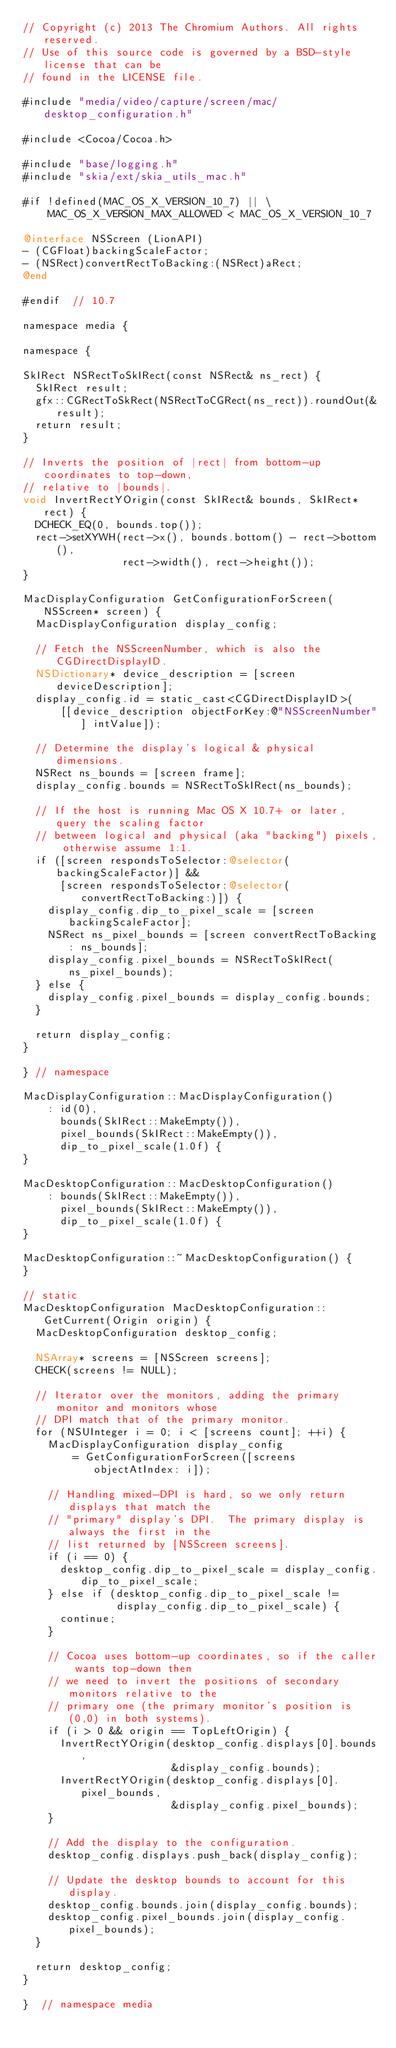<code> <loc_0><loc_0><loc_500><loc_500><_ObjectiveC_>// Copyright (c) 2013 The Chromium Authors. All rights reserved.
// Use of this source code is governed by a BSD-style license that can be
// found in the LICENSE file.

#include "media/video/capture/screen/mac/desktop_configuration.h"

#include <Cocoa/Cocoa.h>

#include "base/logging.h"
#include "skia/ext/skia_utils_mac.h"

#if !defined(MAC_OS_X_VERSION_10_7) || \
    MAC_OS_X_VERSION_MAX_ALLOWED < MAC_OS_X_VERSION_10_7

@interface NSScreen (LionAPI)
- (CGFloat)backingScaleFactor;
- (NSRect)convertRectToBacking:(NSRect)aRect;
@end

#endif  // 10.7

namespace media {

namespace {

SkIRect NSRectToSkIRect(const NSRect& ns_rect) {
  SkIRect result;
  gfx::CGRectToSkRect(NSRectToCGRect(ns_rect)).roundOut(&result);
  return result;
}

// Inverts the position of |rect| from bottom-up coordinates to top-down,
// relative to |bounds|.
void InvertRectYOrigin(const SkIRect& bounds, SkIRect* rect) {
  DCHECK_EQ(0, bounds.top());
  rect->setXYWH(rect->x(), bounds.bottom() - rect->bottom(),
                rect->width(), rect->height());
}

MacDisplayConfiguration GetConfigurationForScreen(NSScreen* screen) {
  MacDisplayConfiguration display_config;

  // Fetch the NSScreenNumber, which is also the CGDirectDisplayID.
  NSDictionary* device_description = [screen deviceDescription];
  display_config.id = static_cast<CGDirectDisplayID>(
      [[device_description objectForKey:@"NSScreenNumber"] intValue]);

  // Determine the display's logical & physical dimensions.
  NSRect ns_bounds = [screen frame];
  display_config.bounds = NSRectToSkIRect(ns_bounds);

  // If the host is running Mac OS X 10.7+ or later, query the scaling factor
  // between logical and physical (aka "backing") pixels, otherwise assume 1:1.
  if ([screen respondsToSelector:@selector(backingScaleFactor)] &&
      [screen respondsToSelector:@selector(convertRectToBacking:)]) {
    display_config.dip_to_pixel_scale = [screen backingScaleFactor];
    NSRect ns_pixel_bounds = [screen convertRectToBacking: ns_bounds];
    display_config.pixel_bounds = NSRectToSkIRect(ns_pixel_bounds);
  } else {
    display_config.pixel_bounds = display_config.bounds;
  }

  return display_config;
}

} // namespace

MacDisplayConfiguration::MacDisplayConfiguration()
    : id(0),
      bounds(SkIRect::MakeEmpty()),
      pixel_bounds(SkIRect::MakeEmpty()),
      dip_to_pixel_scale(1.0f) {
}

MacDesktopConfiguration::MacDesktopConfiguration()
    : bounds(SkIRect::MakeEmpty()),
      pixel_bounds(SkIRect::MakeEmpty()),
      dip_to_pixel_scale(1.0f) {
}

MacDesktopConfiguration::~MacDesktopConfiguration() {
}

// static
MacDesktopConfiguration MacDesktopConfiguration::GetCurrent(Origin origin) {
  MacDesktopConfiguration desktop_config;

  NSArray* screens = [NSScreen screens];
  CHECK(screens != NULL);

  // Iterator over the monitors, adding the primary monitor and monitors whose
  // DPI match that of the primary monitor.
  for (NSUInteger i = 0; i < [screens count]; ++i) {
    MacDisplayConfiguration display_config
        = GetConfigurationForScreen([screens objectAtIndex: i]);

    // Handling mixed-DPI is hard, so we only return displays that match the
    // "primary" display's DPI.  The primary display is always the first in the
    // list returned by [NSScreen screens].
    if (i == 0) {
      desktop_config.dip_to_pixel_scale = display_config.dip_to_pixel_scale;
    } else if (desktop_config.dip_to_pixel_scale !=
               display_config.dip_to_pixel_scale) {
      continue;
    }

    // Cocoa uses bottom-up coordinates, so if the caller wants top-down then
    // we need to invert the positions of secondary monitors relative to the
    // primary one (the primary monitor's position is (0,0) in both systems).
    if (i > 0 && origin == TopLeftOrigin) {
      InvertRectYOrigin(desktop_config.displays[0].bounds,
                        &display_config.bounds);
      InvertRectYOrigin(desktop_config.displays[0].pixel_bounds,
                        &display_config.pixel_bounds);
    }

    // Add the display to the configuration.
    desktop_config.displays.push_back(display_config);

    // Update the desktop bounds to account for this display.
    desktop_config.bounds.join(display_config.bounds);
    desktop_config.pixel_bounds.join(display_config.pixel_bounds);
  }

  return desktop_config;
}

}  // namespace media
</code> 